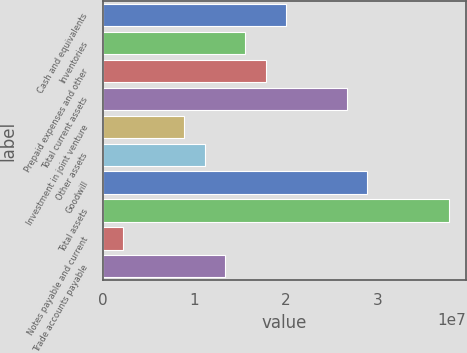<chart> <loc_0><loc_0><loc_500><loc_500><bar_chart><fcel>Cash and equivalents<fcel>Inventories<fcel>Prepaid expenses and other<fcel>Total current assets<fcel>Investment in joint venture<fcel>Other assets<fcel>Goodwill<fcel>Total assets<fcel>Notes payable and current<fcel>Trade accounts payable<nl><fcel>1.99961e+07<fcel>1.55542e+07<fcel>1.77752e+07<fcel>2.66591e+07<fcel>8.89123e+06<fcel>1.11122e+07<fcel>2.88801e+07<fcel>3.7764e+07<fcel>2.22828e+06<fcel>1.33332e+07<nl></chart> 